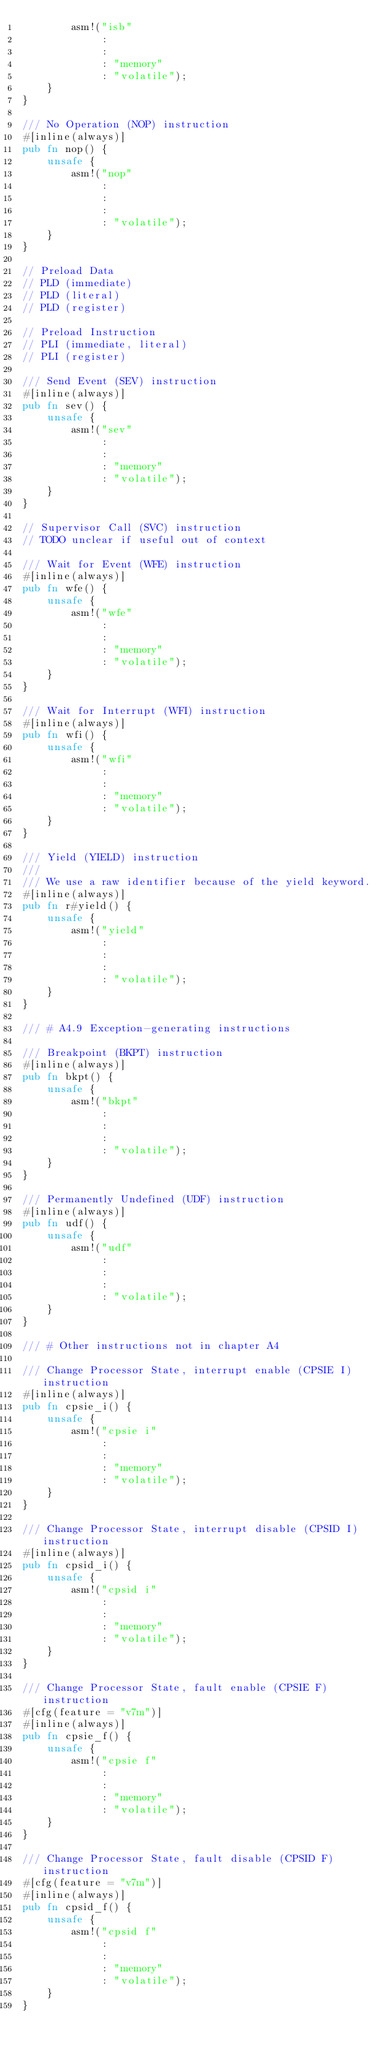Convert code to text. <code><loc_0><loc_0><loc_500><loc_500><_Rust_>        asm!("isb"
             :
             :
             : "memory"
             : "volatile");
    }
}

/// No Operation (NOP) instruction
#[inline(always)]
pub fn nop() {
    unsafe {
        asm!("nop"
             :
             :
             :
             : "volatile");
    }
}

// Preload Data
// PLD (immediate)
// PLD (literal)
// PLD (register)

// Preload Instruction
// PLI (immediate, literal)
// PLI (register)

/// Send Event (SEV) instruction
#[inline(always)]
pub fn sev() {
    unsafe {
        asm!("sev"
             :
             :
             : "memory"
             : "volatile");
    }
}

// Supervisor Call (SVC) instruction
// TODO unclear if useful out of context

/// Wait for Event (WFE) instruction
#[inline(always)]
pub fn wfe() {
    unsafe {
        asm!("wfe"
             :
             :
             : "memory"
             : "volatile");
    }
}

/// Wait for Interrupt (WFI) instruction
#[inline(always)]
pub fn wfi() {
    unsafe {
        asm!("wfi"
             :
             :
             : "memory"
             : "volatile");
    }
}

/// Yield (YIELD) instruction
///
/// We use a raw identifier because of the yield keyword.
#[inline(always)]
pub fn r#yield() {
    unsafe {
        asm!("yield"
             :
             :
             :
             : "volatile");
    }
}

/// # A4.9 Exception-generating instructions

/// Breakpoint (BKPT) instruction
#[inline(always)]
pub fn bkpt() {
    unsafe {
        asm!("bkpt"
             :
             :
             :
             : "volatile");
    }
}

/// Permanently Undefined (UDF) instruction
#[inline(always)]
pub fn udf() {
    unsafe {
        asm!("udf"
             :
             :
             :
             : "volatile");
    }
}

/// # Other instructions not in chapter A4

/// Change Processor State, interrupt enable (CPSIE I) instruction
#[inline(always)]
pub fn cpsie_i() {
    unsafe {
        asm!("cpsie i"
             :
             :
             : "memory"
             : "volatile");
    }
}

/// Change Processor State, interrupt disable (CPSID I) instruction
#[inline(always)]
pub fn cpsid_i() {
    unsafe {
        asm!("cpsid i"
             :
             :
             : "memory"
             : "volatile");
    }
}

/// Change Processor State, fault enable (CPSIE F) instruction
#[cfg(feature = "v7m")]
#[inline(always)]
pub fn cpsie_f() {
    unsafe {
        asm!("cpsie f"
             :
             :
             : "memory"
             : "volatile");
    }
}

/// Change Processor State, fault disable (CPSID F) instruction
#[cfg(feature = "v7m")]
#[inline(always)]
pub fn cpsid_f() {
    unsafe {
        asm!("cpsid f"
             :
             :
             : "memory"
             : "volatile");
    }
}
</code> 